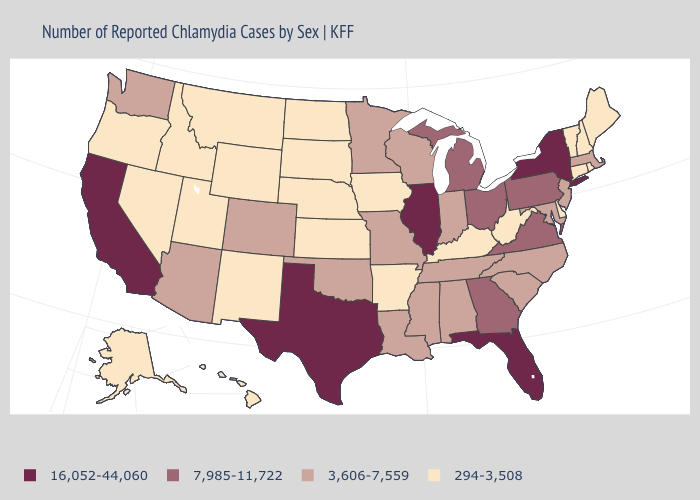Is the legend a continuous bar?
Answer briefly. No. Which states have the lowest value in the South?
Keep it brief. Arkansas, Delaware, Kentucky, West Virginia. Which states have the highest value in the USA?
Be succinct. California, Florida, Illinois, New York, Texas. What is the highest value in states that border South Carolina?
Answer briefly. 7,985-11,722. Among the states that border South Dakota , which have the lowest value?
Concise answer only. Iowa, Montana, Nebraska, North Dakota, Wyoming. What is the lowest value in the MidWest?
Be succinct. 294-3,508. Does Kentucky have a higher value than Alaska?
Quick response, please. No. Does North Carolina have a lower value than Louisiana?
Be succinct. No. Does Montana have the lowest value in the USA?
Short answer required. Yes. Which states have the highest value in the USA?
Short answer required. California, Florida, Illinois, New York, Texas. Name the states that have a value in the range 7,985-11,722?
Short answer required. Georgia, Michigan, Ohio, Pennsylvania, Virginia. Name the states that have a value in the range 3,606-7,559?
Give a very brief answer. Alabama, Arizona, Colorado, Indiana, Louisiana, Maryland, Massachusetts, Minnesota, Mississippi, Missouri, New Jersey, North Carolina, Oklahoma, South Carolina, Tennessee, Washington, Wisconsin. Name the states that have a value in the range 3,606-7,559?
Concise answer only. Alabama, Arizona, Colorado, Indiana, Louisiana, Maryland, Massachusetts, Minnesota, Mississippi, Missouri, New Jersey, North Carolina, Oklahoma, South Carolina, Tennessee, Washington, Wisconsin. Which states have the lowest value in the USA?
Be succinct. Alaska, Arkansas, Connecticut, Delaware, Hawaii, Idaho, Iowa, Kansas, Kentucky, Maine, Montana, Nebraska, Nevada, New Hampshire, New Mexico, North Dakota, Oregon, Rhode Island, South Dakota, Utah, Vermont, West Virginia, Wyoming. What is the value of Montana?
Give a very brief answer. 294-3,508. 